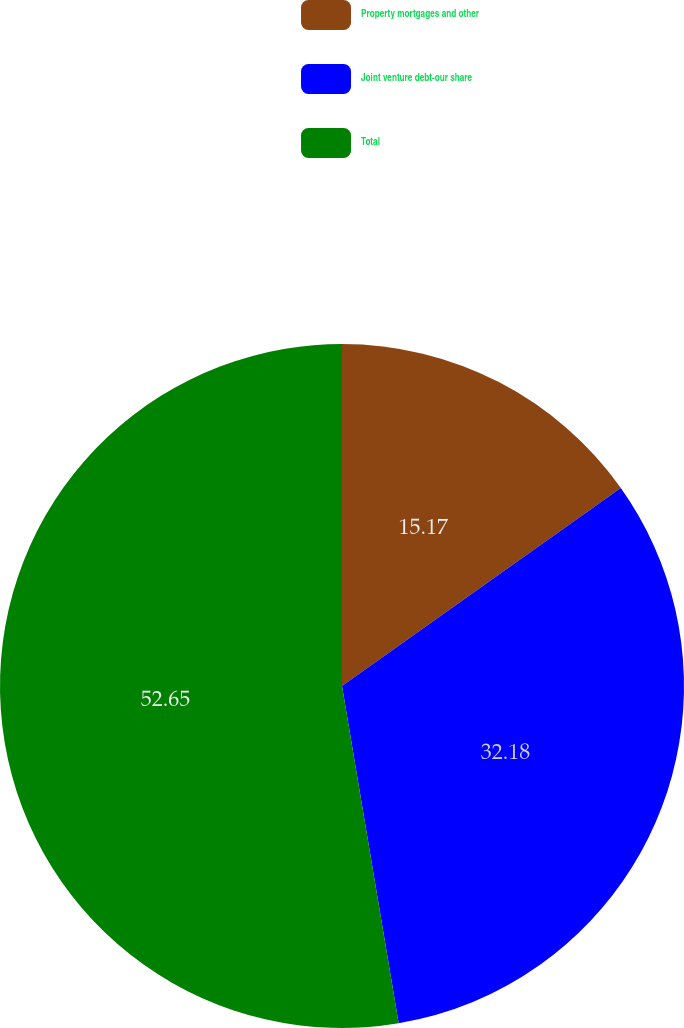<chart> <loc_0><loc_0><loc_500><loc_500><pie_chart><fcel>Property mortgages and other<fcel>Joint venture debt-our share<fcel>Total<nl><fcel>15.17%<fcel>32.18%<fcel>52.65%<nl></chart> 